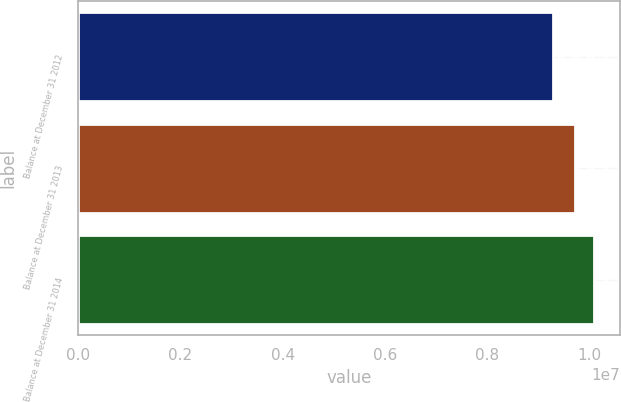Convert chart. <chart><loc_0><loc_0><loc_500><loc_500><bar_chart><fcel>Balance at December 31 2012<fcel>Balance at December 31 2013<fcel>Balance at December 31 2014<nl><fcel>9.29109e+06<fcel>9.72647e+06<fcel>1.01017e+07<nl></chart> 